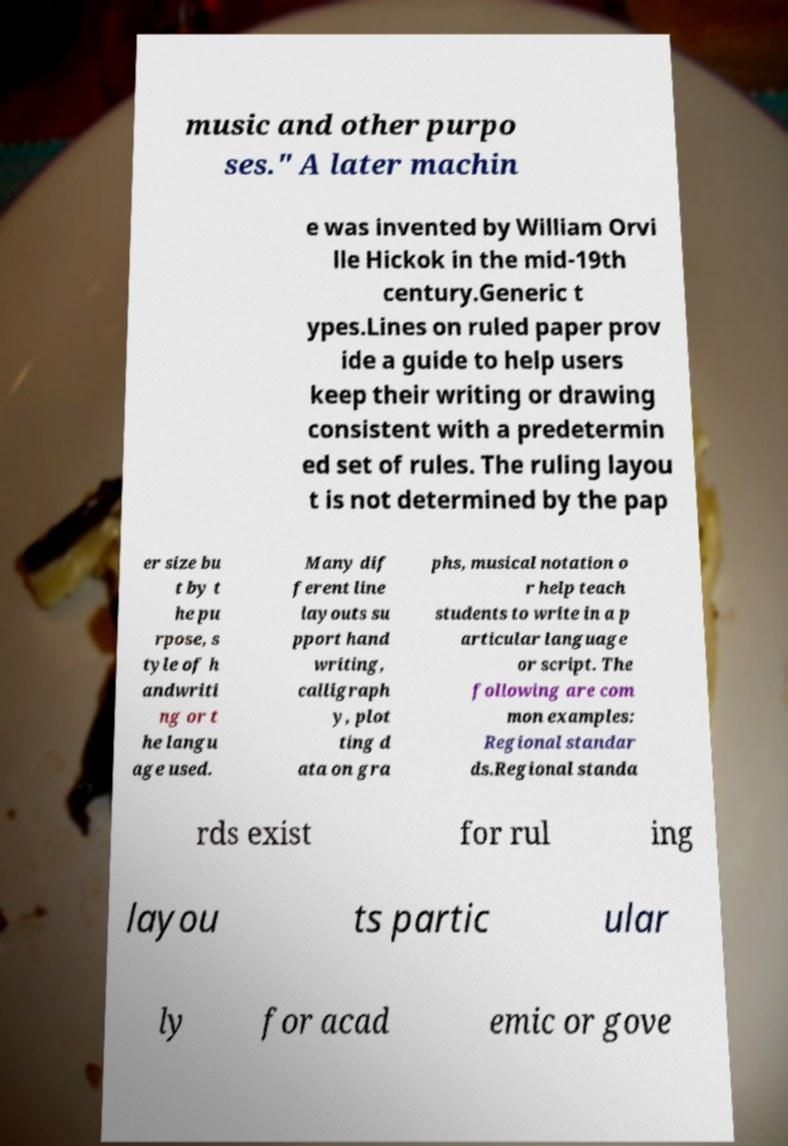There's text embedded in this image that I need extracted. Can you transcribe it verbatim? music and other purpo ses." A later machin e was invented by William Orvi lle Hickok in the mid-19th century.Generic t ypes.Lines on ruled paper prov ide a guide to help users keep their writing or drawing consistent with a predetermin ed set of rules. The ruling layou t is not determined by the pap er size bu t by t he pu rpose, s tyle of h andwriti ng or t he langu age used. Many dif ferent line layouts su pport hand writing, calligraph y, plot ting d ata on gra phs, musical notation o r help teach students to write in a p articular language or script. The following are com mon examples: Regional standar ds.Regional standa rds exist for rul ing layou ts partic ular ly for acad emic or gove 